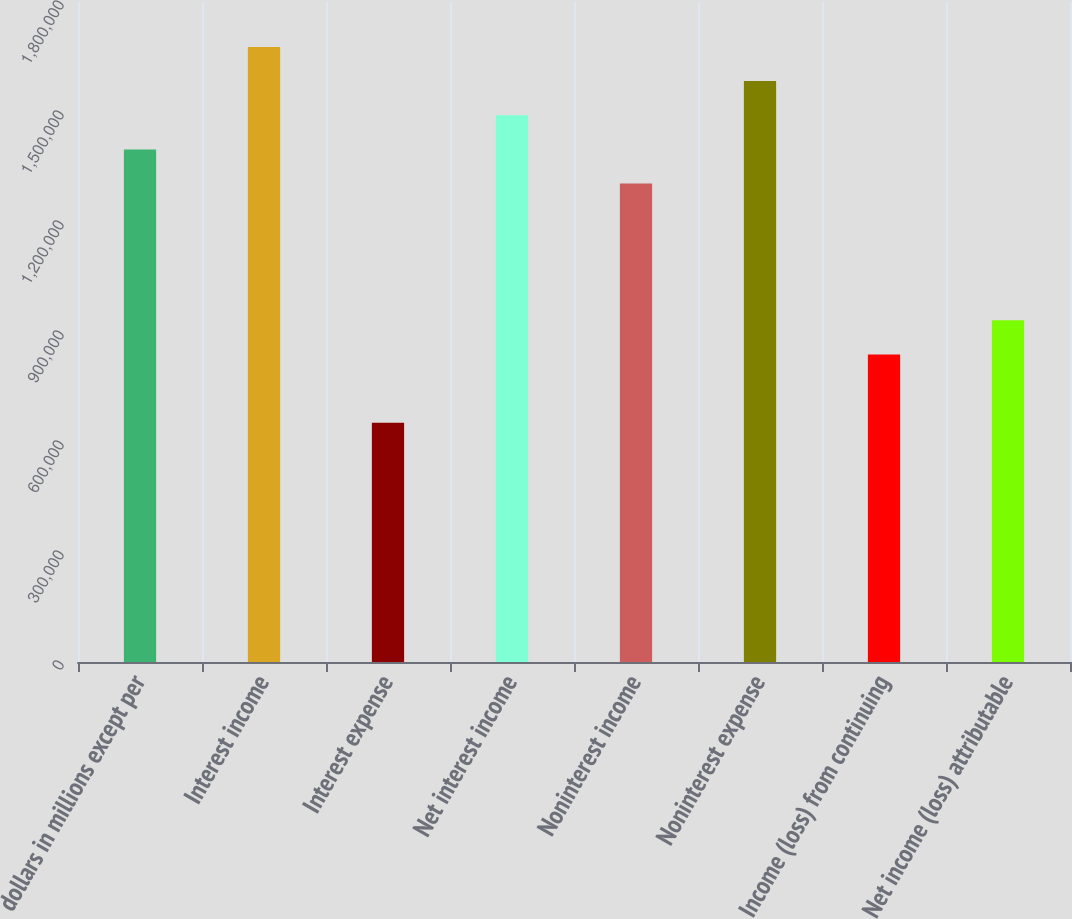Convert chart to OTSL. <chart><loc_0><loc_0><loc_500><loc_500><bar_chart><fcel>dollars in millions except per<fcel>Interest income<fcel>Interest expense<fcel>Net interest income<fcel>Noninterest income<fcel>Noninterest expense<fcel>Income (loss) from continuing<fcel>Net income (loss) attributable<nl><fcel>1.3979e+06<fcel>1.67748e+06<fcel>652354<fcel>1.49109e+06<fcel>1.30471e+06<fcel>1.58429e+06<fcel>838741<fcel>931934<nl></chart> 